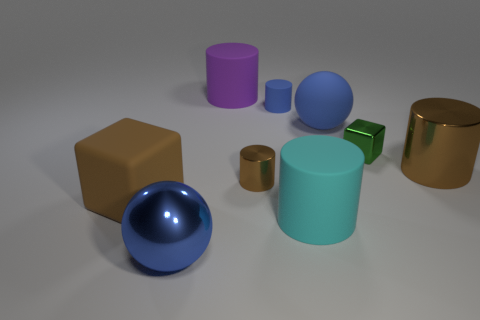Is the size of the blue rubber ball the same as the metallic cube?
Your answer should be very brief. No. There is a big cylinder that is the same color as the large cube; what material is it?
Provide a succinct answer. Metal. There is a small cylinder that is behind the large blue matte sphere; is it the same color as the large matte sphere?
Offer a very short reply. Yes. How big is the cyan matte cylinder?
Provide a short and direct response. Large. What is the color of the sphere behind the small metallic cylinder?
Give a very brief answer. Blue. What number of large purple cylinders are there?
Offer a very short reply. 1. Is there a big object that is in front of the big purple matte cylinder that is behind the large matte object in front of the large matte block?
Your answer should be compact. Yes. The cyan rubber thing that is the same size as the blue rubber sphere is what shape?
Make the answer very short. Cylinder. How many other things are the same color as the metal ball?
Give a very brief answer. 2. What is the material of the cyan cylinder?
Offer a very short reply. Rubber. 